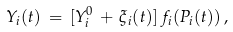Convert formula to latex. <formula><loc_0><loc_0><loc_500><loc_500>Y _ { i } ( t ) \, = \, [ Y _ { i } ^ { 0 } \, + \, \xi _ { i } ( t ) ] \, f _ { i } ( P _ { i } ( t ) ) \, ,</formula> 